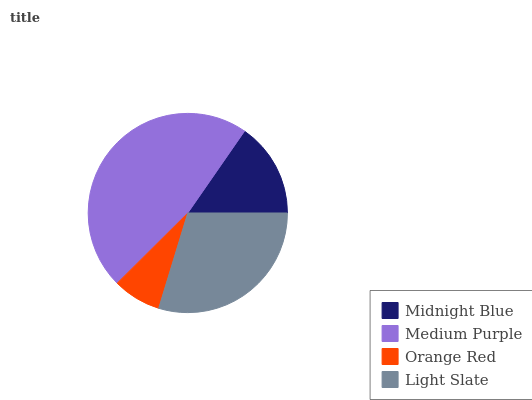Is Orange Red the minimum?
Answer yes or no. Yes. Is Medium Purple the maximum?
Answer yes or no. Yes. Is Medium Purple the minimum?
Answer yes or no. No. Is Orange Red the maximum?
Answer yes or no. No. Is Medium Purple greater than Orange Red?
Answer yes or no. Yes. Is Orange Red less than Medium Purple?
Answer yes or no. Yes. Is Orange Red greater than Medium Purple?
Answer yes or no. No. Is Medium Purple less than Orange Red?
Answer yes or no. No. Is Light Slate the high median?
Answer yes or no. Yes. Is Midnight Blue the low median?
Answer yes or no. Yes. Is Orange Red the high median?
Answer yes or no. No. Is Light Slate the low median?
Answer yes or no. No. 